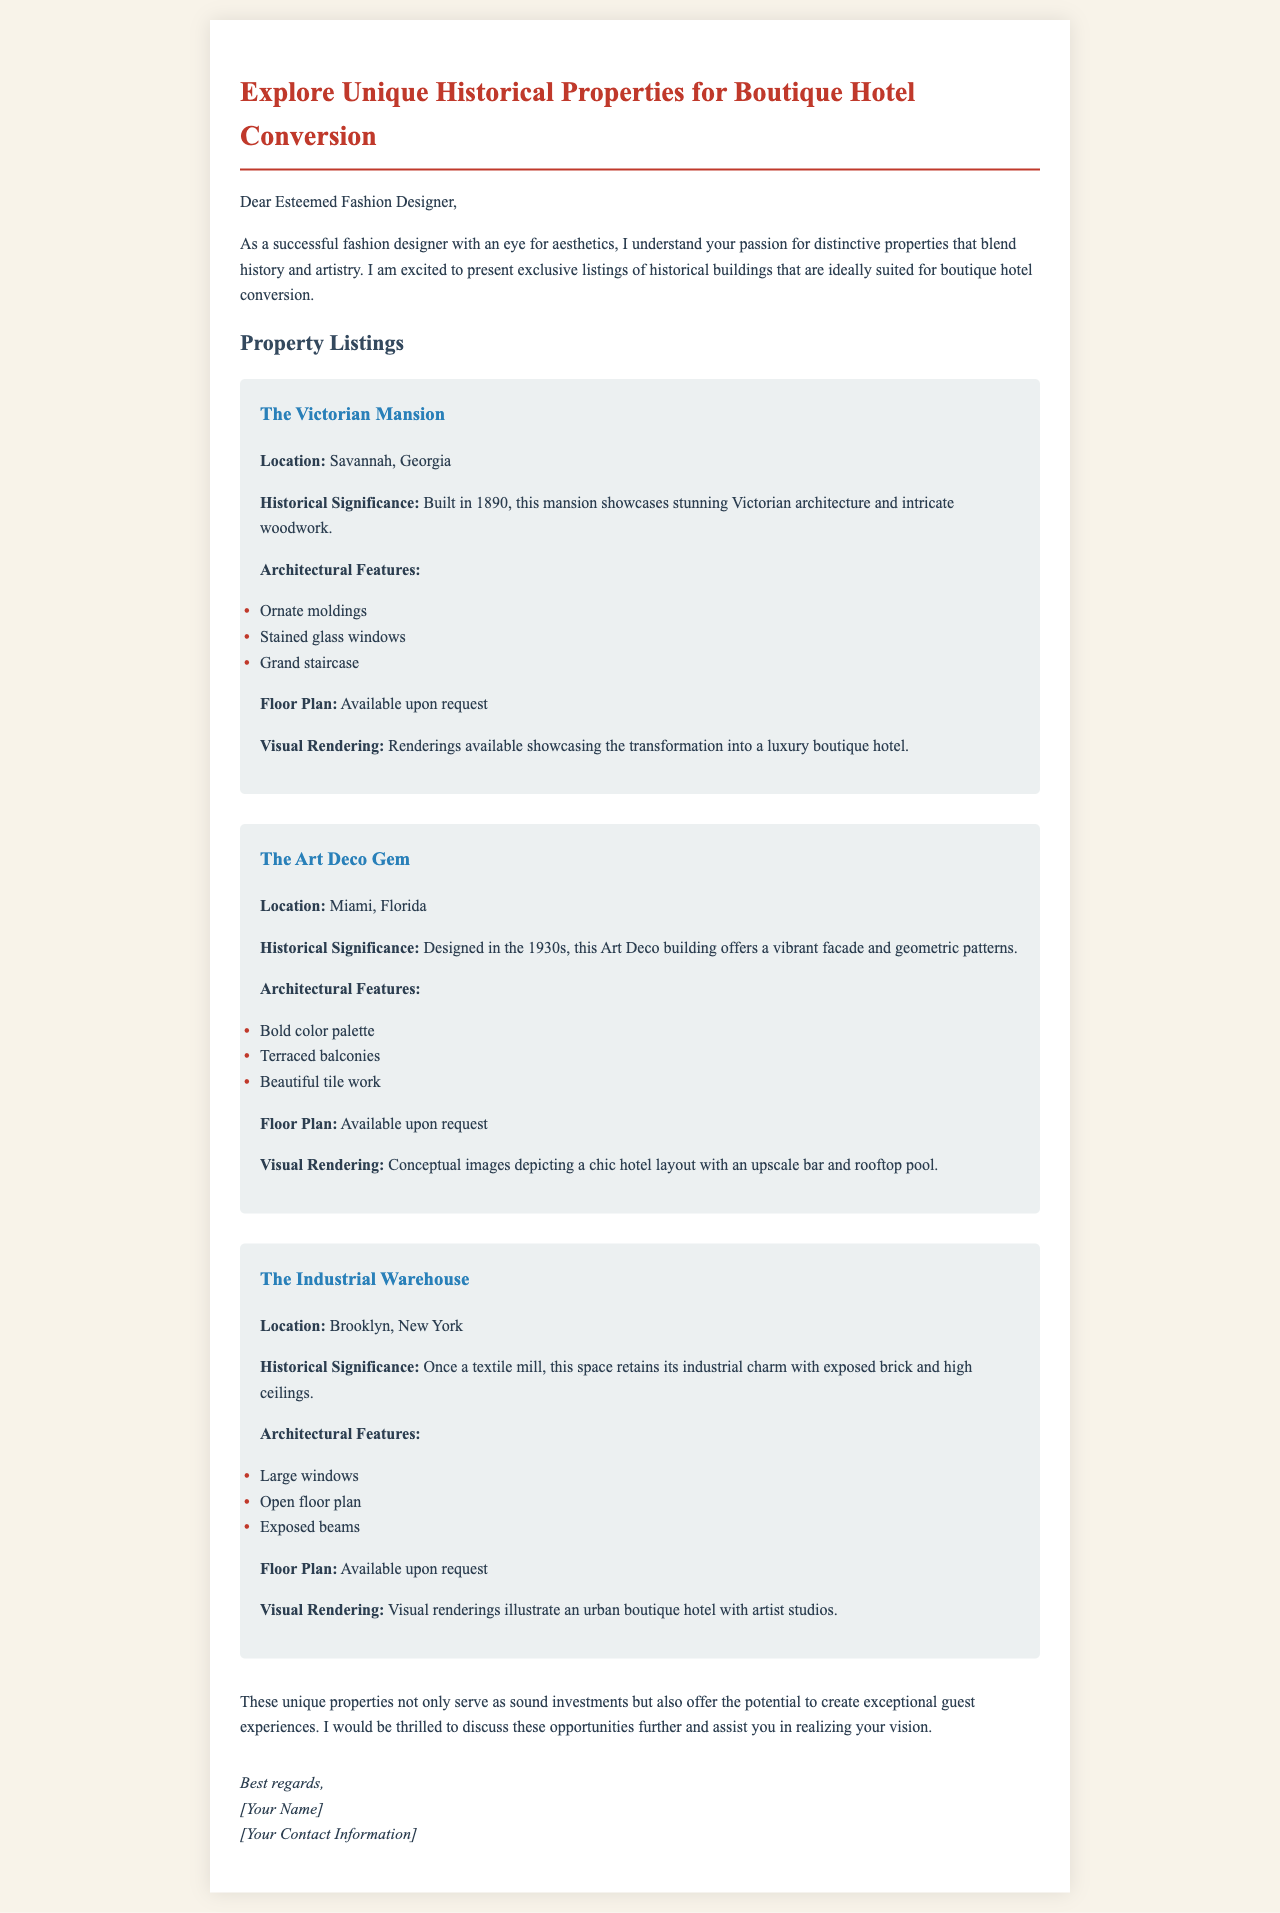What is the location of The Victorian Mansion? The location is specified in the property listing.
Answer: Savannah, Georgia What is the historical significance of The Art Deco Gem? The historical significance is noted in the description of the property.
Answer: Designed in the 1930s What architectural feature is mentioned for The Industrial Warehouse? The architectural features are listed for each property.
Answer: Exposed beams What type of rendering is available for The Victorian Mansion? The type of rendering available is described in the property details.
Answer: Visual renderings How many properties are listed in the document? The total number of properties can be counted from the listings.
Answer: Three Which city is The Industrial Warehouse located in? The location is provided in the property details.
Answer: Brooklyn, New York What is the architectural style of The Art Deco Gem? The architectural style is indicated in the description.
Answer: Art Deco What unique feature does The Victorian Mansion showcase? The unique features are highlighted in the listing for the mansion.
Answer: Intricate woodwork What is the potential use mentioned for these unique properties? The potential use is discussed in the closing paragraph of the document.
Answer: Boutique hotel conversion 